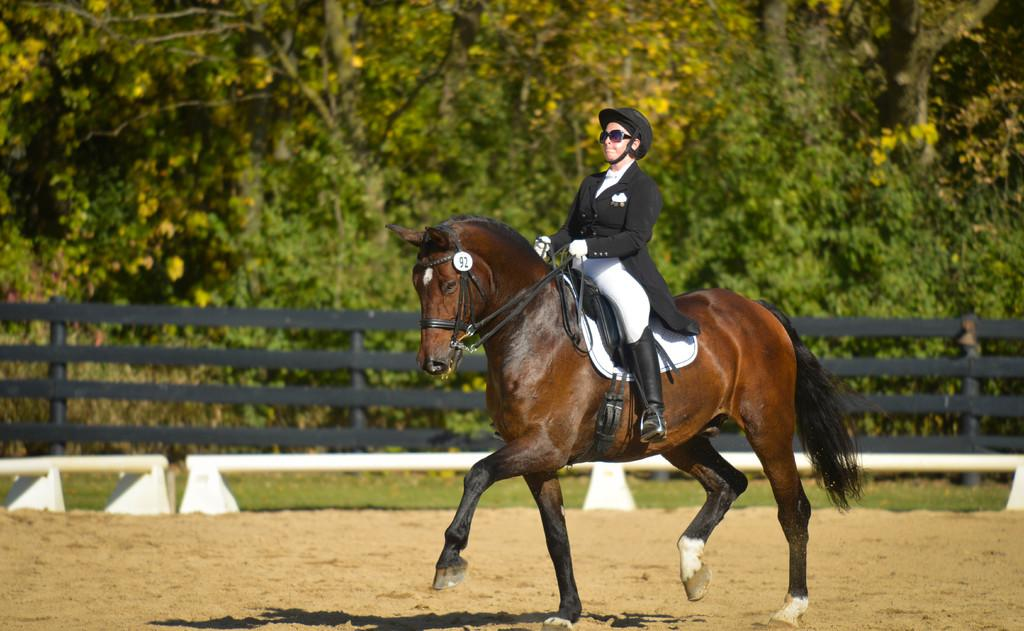What is the main subject of the image? There is a person sitting on a horse in the image. What can be seen in the background of the image? There is a tree, a fence, and grass in the background of the image. What type of club is the person holding in the image? There is no club present in the image; the person is sitting on a horse. What color is the floor in the image? There is no floor present in the image; it is an outdoor scene with grass. 